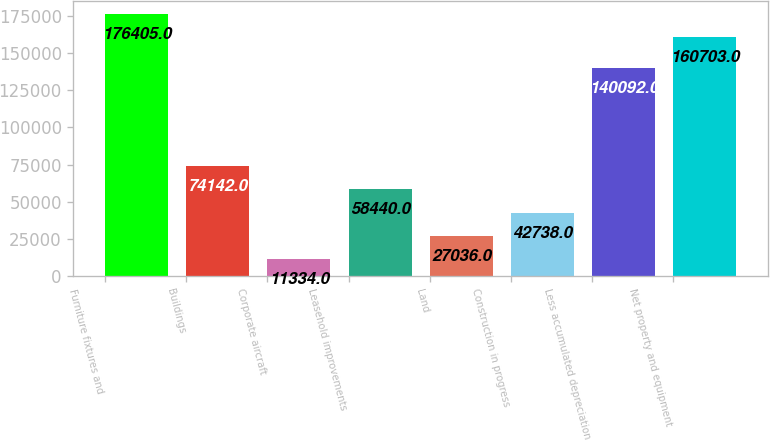<chart> <loc_0><loc_0><loc_500><loc_500><bar_chart><fcel>Furniture fixtures and<fcel>Buildings<fcel>Corporate aircraft<fcel>Leasehold improvements<fcel>Land<fcel>Construction in progress<fcel>Less accumulated depreciation<fcel>Net property and equipment<nl><fcel>176405<fcel>74142<fcel>11334<fcel>58440<fcel>27036<fcel>42738<fcel>140092<fcel>160703<nl></chart> 